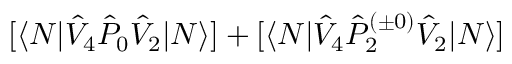Convert formula to latex. <formula><loc_0><loc_0><loc_500><loc_500>[ \langle N | \hat { V } _ { 4 } \hat { P } _ { 0 } \hat { V } _ { 2 } | N \rangle ] + [ \langle N | \hat { V } _ { 4 } \hat { P } _ { 2 } ^ { ( \pm 0 ) } \hat { V } _ { 2 } | N \rangle ]</formula> 